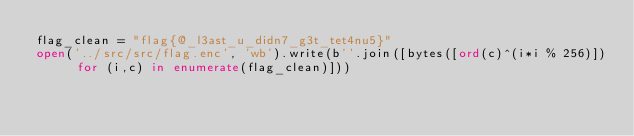Convert code to text. <code><loc_0><loc_0><loc_500><loc_500><_Python_>flag_clean = "flag{@_l3ast_u_didn7_g3t_tet4nu5}"
open('../src/src/flag.enc', 'wb').write(b''.join([bytes([ord(c)^(i*i % 256)]) for (i,c) in enumerate(flag_clean)]))
</code> 